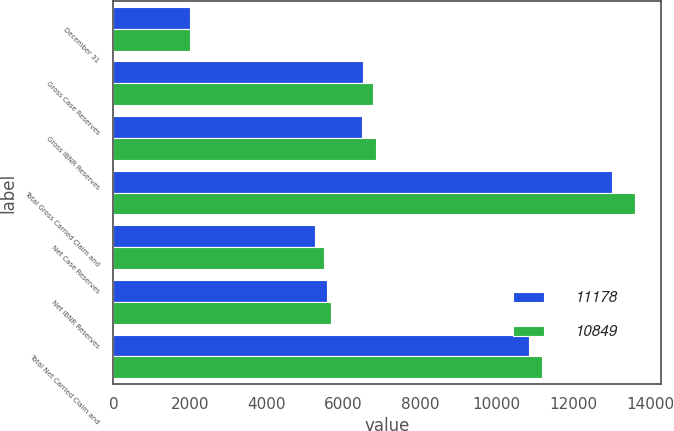Convert chart. <chart><loc_0><loc_0><loc_500><loc_500><stacked_bar_chart><ecel><fcel>December 31<fcel>Gross Case Reserves<fcel>Gross IBNR Reserves<fcel>Total Gross Carried Claim and<fcel>Net Case Reserves<fcel>Net IBNR Reserves<fcel>Total Net Carried Claim and<nl><fcel>11178<fcel>2009<fcel>6510<fcel>6495<fcel>13005<fcel>5269<fcel>5580<fcel>10849<nl><fcel>10849<fcel>2008<fcel>6772<fcel>6837<fcel>13609<fcel>5505<fcel>5673<fcel>11178<nl></chart> 